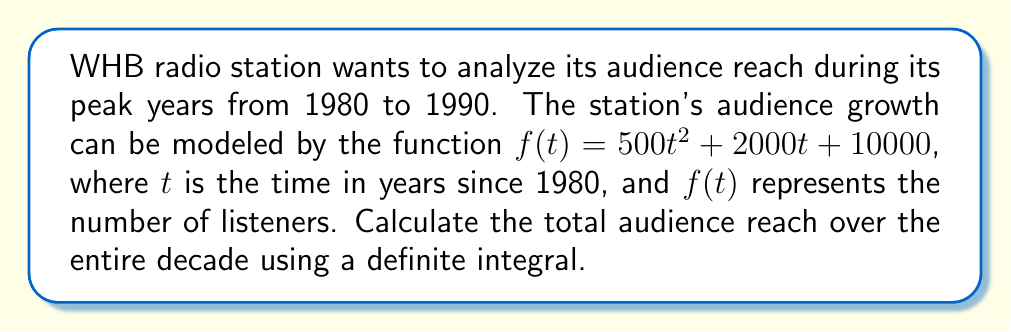Can you solve this math problem? To solve this problem, we need to use a definite integral to calculate the area under the curve of the audience growth function over the given time period.

1) The function representing audience growth is:
   $f(t) = 500t^2 + 2000t + 10000$

2) We need to integrate this function from $t=0$ (1980) to $t=10$ (1990):

   $$\int_0^{10} (500t^2 + 2000t + 10000) dt$$

3) Let's integrate each term separately:

   $$\int_0^{10} 500t^2 dt + \int_0^{10} 2000t dt + \int_0^{10} 10000 dt$$

4) Integrating:
   
   $$\left[ \frac{500t^3}{3} \right]_0^{10} + \left[ 1000t^2 \right]_0^{10} + \left[ 10000t \right]_0^{10}$$

5) Evaluating the definite integral:

   $$\left(\frac{500(10^3)}{3} - \frac{500(0^3)}{3}\right) + (1000(10^2) - 1000(0^2)) + (10000(10) - 10000(0))$$

6) Simplifying:

   $$\frac{500000}{3} + 100000 + 100000$$

7) Adding the terms:

   $$166666.67 + 100000 + 100000 = 366666.67$$

This result represents the total audience reach over the decade, measured in listener-years.
Answer: The total audience reach from 1980 to 1990 is approximately 366,667 listener-years. 